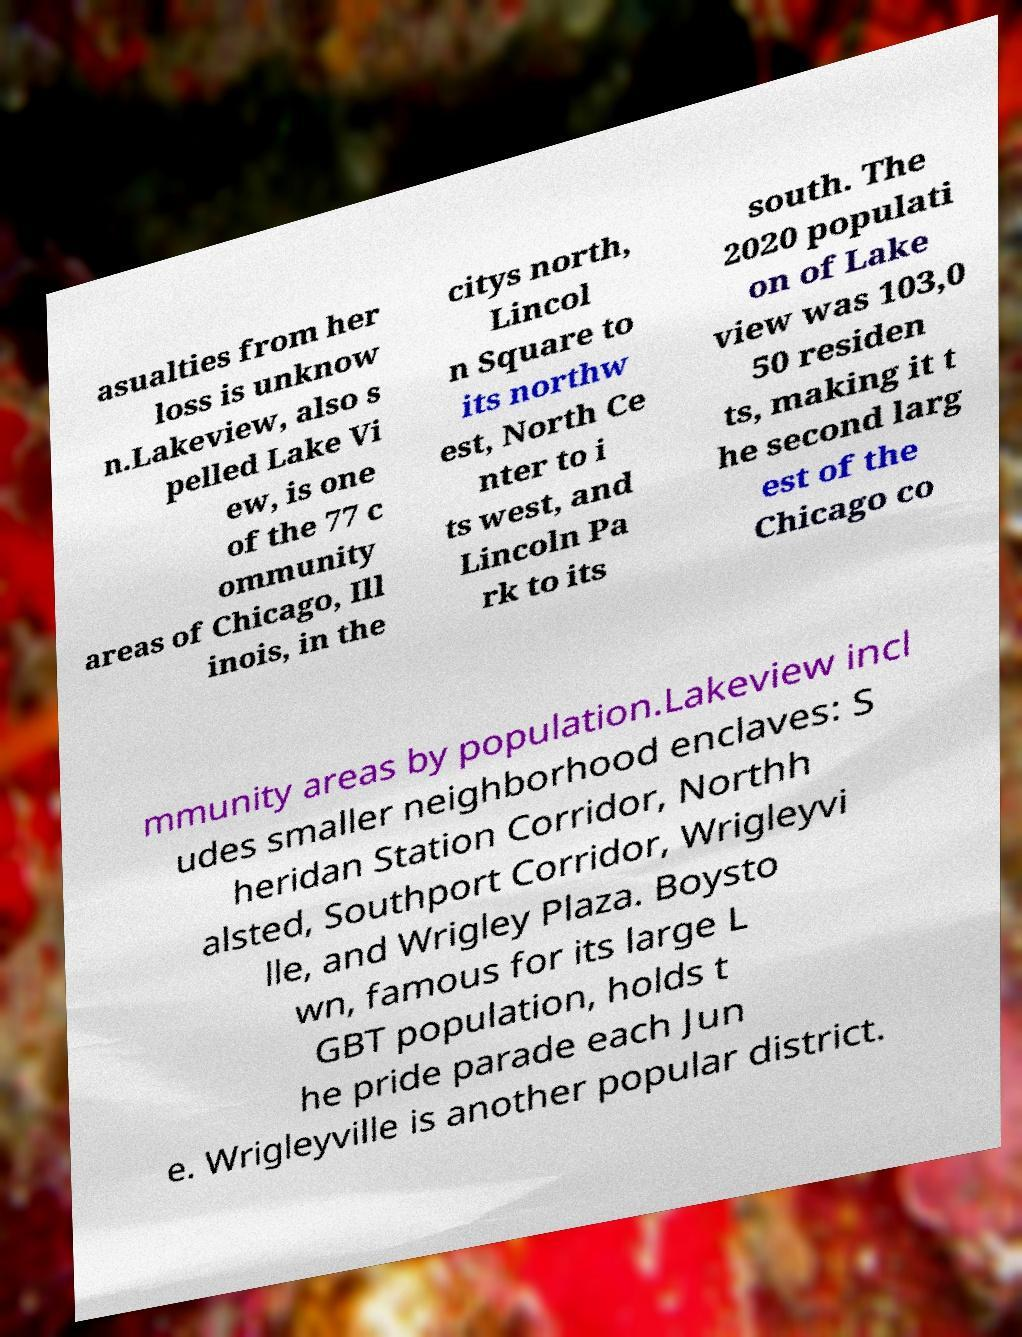Please identify and transcribe the text found in this image. asualties from her loss is unknow n.Lakeview, also s pelled Lake Vi ew, is one of the 77 c ommunity areas of Chicago, Ill inois, in the citys north, Lincol n Square to its northw est, North Ce nter to i ts west, and Lincoln Pa rk to its south. The 2020 populati on of Lake view was 103,0 50 residen ts, making it t he second larg est of the Chicago co mmunity areas by population.Lakeview incl udes smaller neighborhood enclaves: S heridan Station Corridor, Northh alsted, Southport Corridor, Wrigleyvi lle, and Wrigley Plaza. Boysto wn, famous for its large L GBT population, holds t he pride parade each Jun e. Wrigleyville is another popular district. 